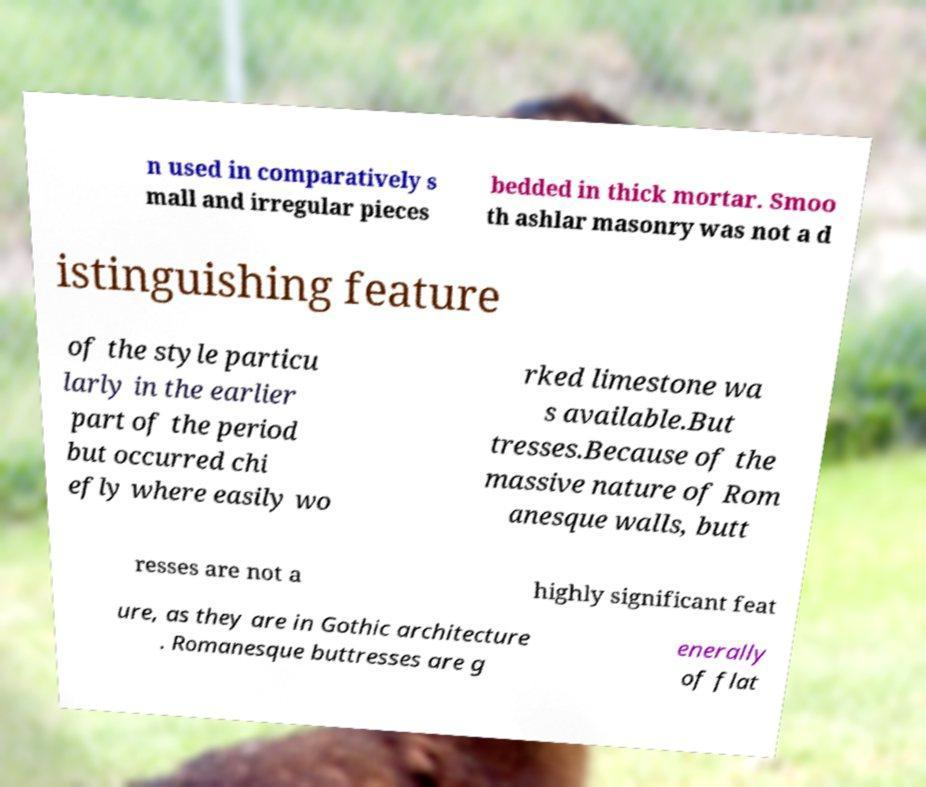There's text embedded in this image that I need extracted. Can you transcribe it verbatim? n used in comparatively s mall and irregular pieces bedded in thick mortar. Smoo th ashlar masonry was not a d istinguishing feature of the style particu larly in the earlier part of the period but occurred chi efly where easily wo rked limestone wa s available.But tresses.Because of the massive nature of Rom anesque walls, butt resses are not a highly significant feat ure, as they are in Gothic architecture . Romanesque buttresses are g enerally of flat 